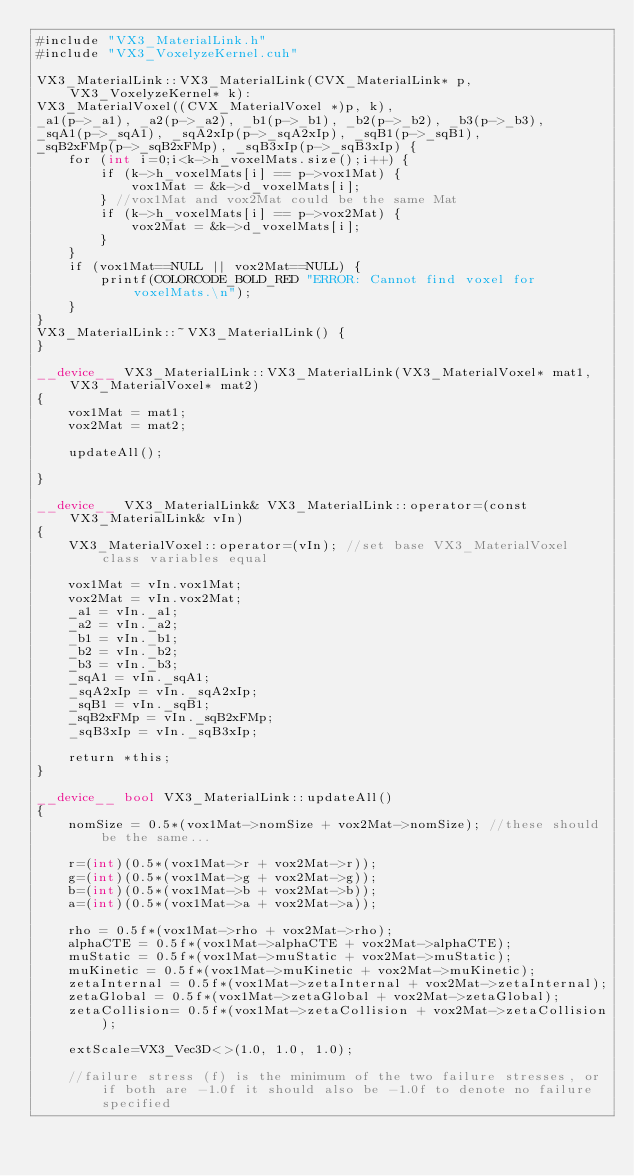<code> <loc_0><loc_0><loc_500><loc_500><_Cuda_>#include "VX3_MaterialLink.h"
#include "VX3_VoxelyzeKernel.cuh"

VX3_MaterialLink::VX3_MaterialLink(CVX_MaterialLink* p, VX3_VoxelyzeKernel* k):
VX3_MaterialVoxel((CVX_MaterialVoxel *)p, k),
_a1(p->_a1), _a2(p->_a2), _b1(p->_b1), _b2(p->_b2), _b3(p->_b3),
_sqA1(p->_sqA1), _sqA2xIp(p->_sqA2xIp), _sqB1(p->_sqB1), 
_sqB2xFMp(p->_sqB2xFMp), _sqB3xIp(p->_sqB3xIp) {
	for (int i=0;i<k->h_voxelMats.size();i++) {
		if (k->h_voxelMats[i] == p->vox1Mat) {
			vox1Mat = &k->d_voxelMats[i];
		} //vox1Mat and vox2Mat could be the same Mat
		if (k->h_voxelMats[i] == p->vox2Mat) {
			vox2Mat = &k->d_voxelMats[i];
		}
	}
	if (vox1Mat==NULL || vox2Mat==NULL) {
		printf(COLORCODE_BOLD_RED "ERROR: Cannot find voxel for voxelMats.\n");
	}
}
VX3_MaterialLink::~VX3_MaterialLink() {
}

__device__ VX3_MaterialLink::VX3_MaterialLink(VX3_MaterialVoxel* mat1, VX3_MaterialVoxel* mat2)
{
	vox1Mat = mat1;
	vox2Mat = mat2;

	updateAll();

}

__device__ VX3_MaterialLink& VX3_MaterialLink::operator=(const VX3_MaterialLink& vIn)
{
	VX3_MaterialVoxel::operator=(vIn); //set base VX3_MaterialVoxel class variables equal

	vox1Mat = vIn.vox1Mat;
	vox2Mat = vIn.vox2Mat;
	_a1 = vIn._a1;
	_a2 = vIn._a2;
	_b1 = vIn._b1;
	_b2 = vIn._b2;
	_b3 = vIn._b3;
	_sqA1 = vIn._sqA1;
	_sqA2xIp = vIn._sqA2xIp;
	_sqB1 = vIn._sqB1;
	_sqB2xFMp = vIn._sqB2xFMp;
	_sqB3xIp = vIn._sqB3xIp;

	return *this;
}

__device__ bool VX3_MaterialLink::updateAll()
{
	nomSize = 0.5*(vox1Mat->nomSize + vox2Mat->nomSize); //these should be the same...

	r=(int)(0.5*(vox1Mat->r + vox2Mat->r));
	g=(int)(0.5*(vox1Mat->g + vox2Mat->g));
	b=(int)(0.5*(vox1Mat->b + vox2Mat->b));
	a=(int)(0.5*(vox1Mat->a + vox2Mat->a));

	rho = 0.5f*(vox1Mat->rho + vox2Mat->rho);
	alphaCTE = 0.5f*(vox1Mat->alphaCTE + vox2Mat->alphaCTE);
	muStatic = 0.5f*(vox1Mat->muStatic + vox2Mat->muStatic);
	muKinetic = 0.5f*(vox1Mat->muKinetic + vox2Mat->muKinetic);
	zetaInternal = 0.5f*(vox1Mat->zetaInternal + vox2Mat->zetaInternal);
	zetaGlobal = 0.5f*(vox1Mat->zetaGlobal + vox2Mat->zetaGlobal);
	zetaCollision= 0.5f*(vox1Mat->zetaCollision + vox2Mat->zetaCollision);

	extScale=VX3_Vec3D<>(1.0, 1.0, 1.0);

	//failure stress (f) is the minimum of the two failure stresses, or if both are -1.0f it should also be -1.0f to denote no failure specified</code> 